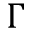Convert formula to latex. <formula><loc_0><loc_0><loc_500><loc_500>\Gamma</formula> 